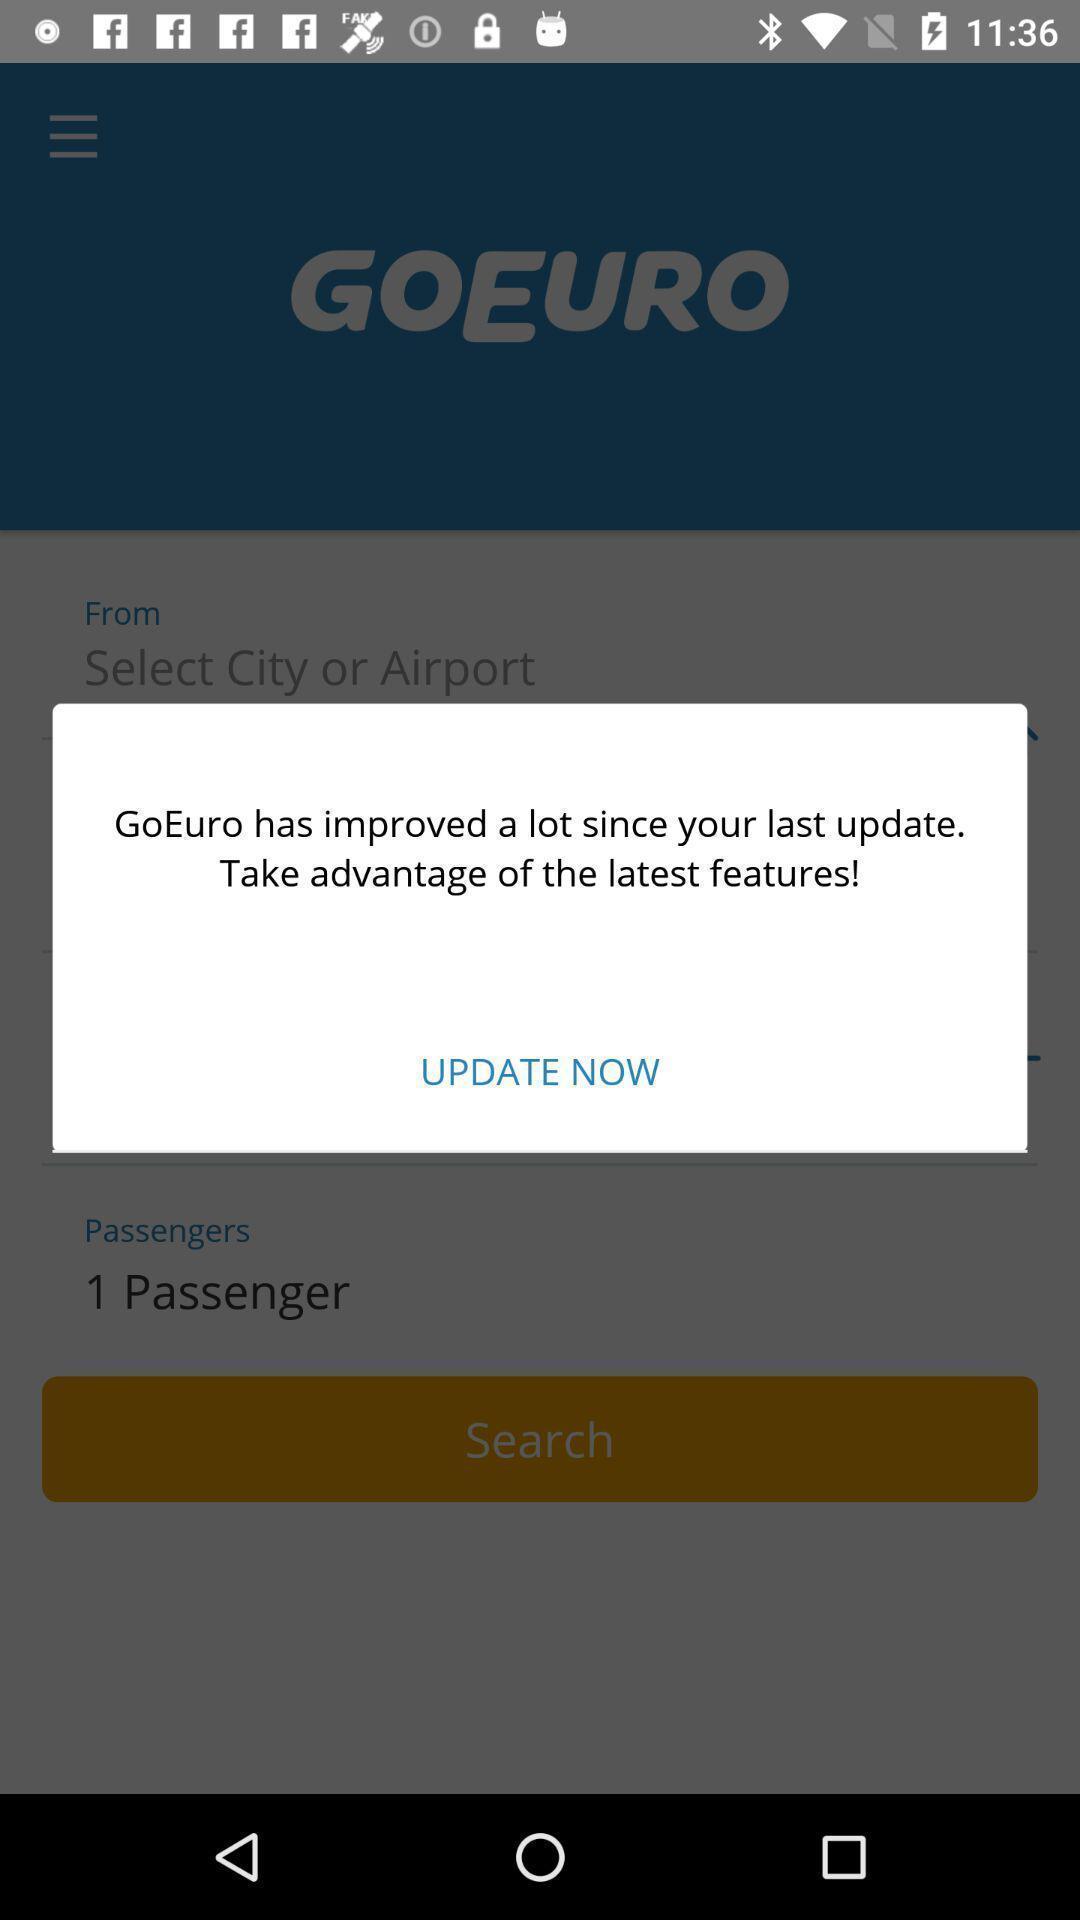Describe the visual elements of this screenshot. Pop-up showing an update option. 